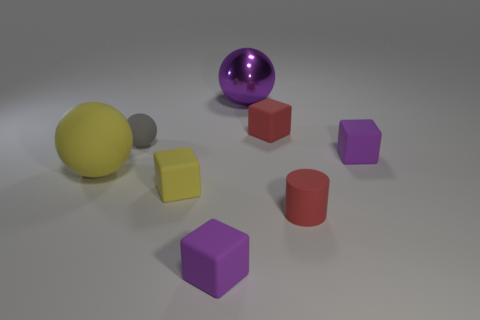What is the color of the small rubber cube behind the purple thing that is to the right of the big thing to the right of the yellow matte sphere?
Your answer should be compact. Red. What number of other objects are there of the same color as the big matte thing?
Give a very brief answer. 1. Are there fewer shiny spheres than tiny matte cubes?
Keep it short and to the point. Yes. What color is the object that is both to the left of the tiny red cube and behind the tiny matte sphere?
Offer a very short reply. Purple. What material is the tiny thing that is the same shape as the big yellow object?
Provide a short and direct response. Rubber. Are there more large purple balls than balls?
Your answer should be compact. No. There is a purple thing that is on the left side of the small matte cylinder and behind the big matte ball; what size is it?
Your answer should be very brief. Large. There is a tiny gray rubber thing; what shape is it?
Ensure brevity in your answer.  Sphere. What number of purple rubber things have the same shape as the gray object?
Your answer should be very brief. 0. Are there fewer yellow matte blocks that are on the right side of the purple metal ball than tiny purple rubber blocks that are on the right side of the red matte cylinder?
Your answer should be very brief. Yes. 